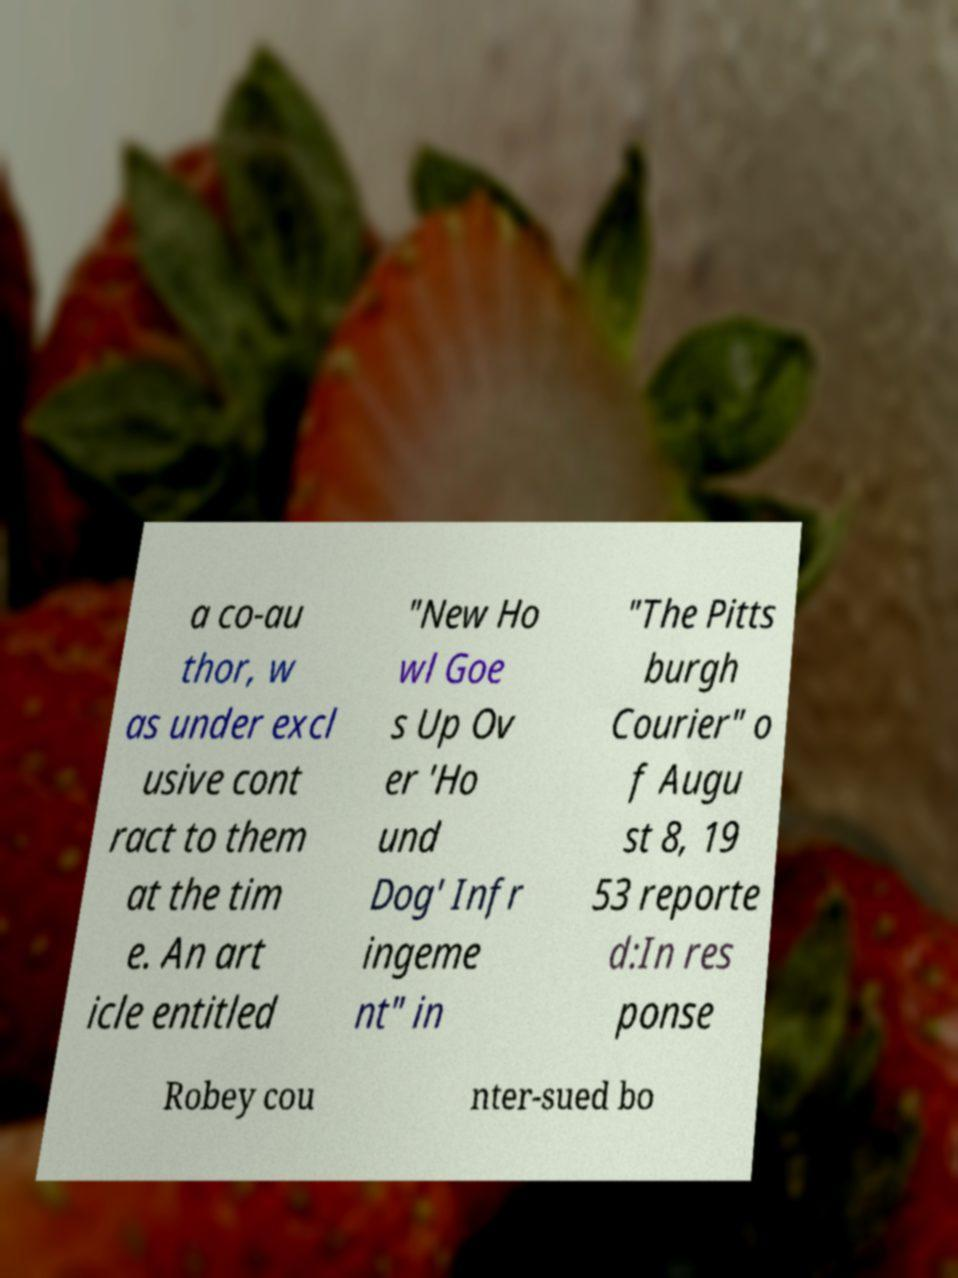Could you assist in decoding the text presented in this image and type it out clearly? a co-au thor, w as under excl usive cont ract to them at the tim e. An art icle entitled "New Ho wl Goe s Up Ov er 'Ho und Dog' Infr ingeme nt" in "The Pitts burgh Courier" o f Augu st 8, 19 53 reporte d:In res ponse Robey cou nter-sued bo 